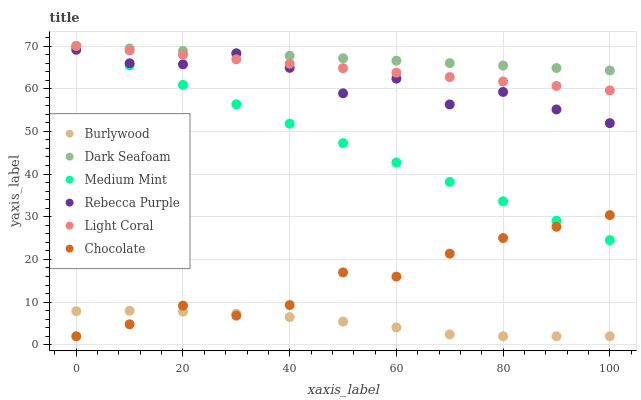Does Burlywood have the minimum area under the curve?
Answer yes or no. Yes. Does Dark Seafoam have the maximum area under the curve?
Answer yes or no. Yes. Does Chocolate have the minimum area under the curve?
Answer yes or no. No. Does Chocolate have the maximum area under the curve?
Answer yes or no. No. Is Dark Seafoam the smoothest?
Answer yes or no. Yes. Is Rebecca Purple the roughest?
Answer yes or no. Yes. Is Burlywood the smoothest?
Answer yes or no. No. Is Burlywood the roughest?
Answer yes or no. No. Does Burlywood have the lowest value?
Answer yes or no. Yes. Does Light Coral have the lowest value?
Answer yes or no. No. Does Dark Seafoam have the highest value?
Answer yes or no. Yes. Does Chocolate have the highest value?
Answer yes or no. No. Is Burlywood less than Dark Seafoam?
Answer yes or no. Yes. Is Dark Seafoam greater than Burlywood?
Answer yes or no. Yes. Does Medium Mint intersect Light Coral?
Answer yes or no. Yes. Is Medium Mint less than Light Coral?
Answer yes or no. No. Is Medium Mint greater than Light Coral?
Answer yes or no. No. Does Burlywood intersect Dark Seafoam?
Answer yes or no. No. 